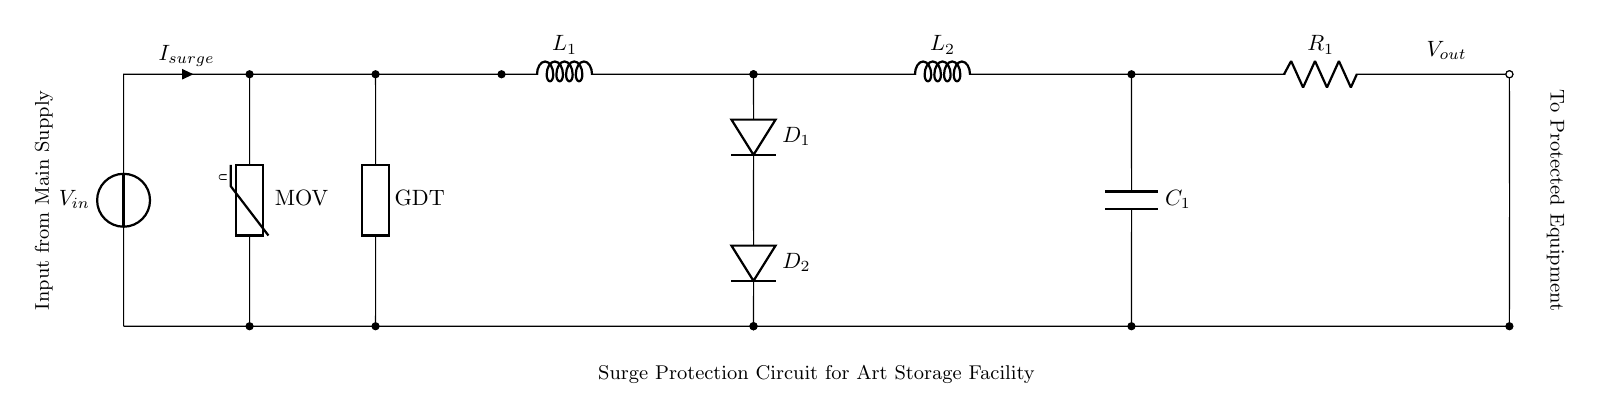What does MOV stand for in this circuit? MOV stands for Metal Oxide Varistor, which is used for surge protection. It absorbs excess voltage during surges, protecting downstream devices.
Answer: Metal Oxide Varistor What type of circuit component is used as the first line of defense against surges? The first line of defense is the Metal Oxide Varistor (MOV), which reacts to over-voltage conditions by clamping excess voltage.
Answer: Metal Oxide Varistor How many diodes are present in this circuit? The circuit includes two diodes, labeled D1 and D2, which are used for ensuring current flow in one direction and provide additional surge protection.
Answer: Two What is the purpose of the inductor L1 in this circuit? Inductor L1 is used to filter out noise and smooth transient responses, which can help protect sensitive electronic components by reducing current spikes.
Answer: Filtering What is the output voltage symbol denoted in the circuit? The output voltage is denoted by Vout, which represents the voltage supplied to protected equipment after surge protection measures have been applied.
Answer: Vout Why are resistors used in surge protection circuits like this one? Resistors, like R1 in this circuit, help limit current flow and dissipate excess energy during surge events, providing enhanced safety to the connected devices.
Answer: Limit current What is the function of capacitor C1 in this circuit? Capacitor C1 is used to filter and stabilize voltage levels, absorbing spikes and smoothing out the power for the protected electronic equipment.
Answer: Stabilizing voltage 